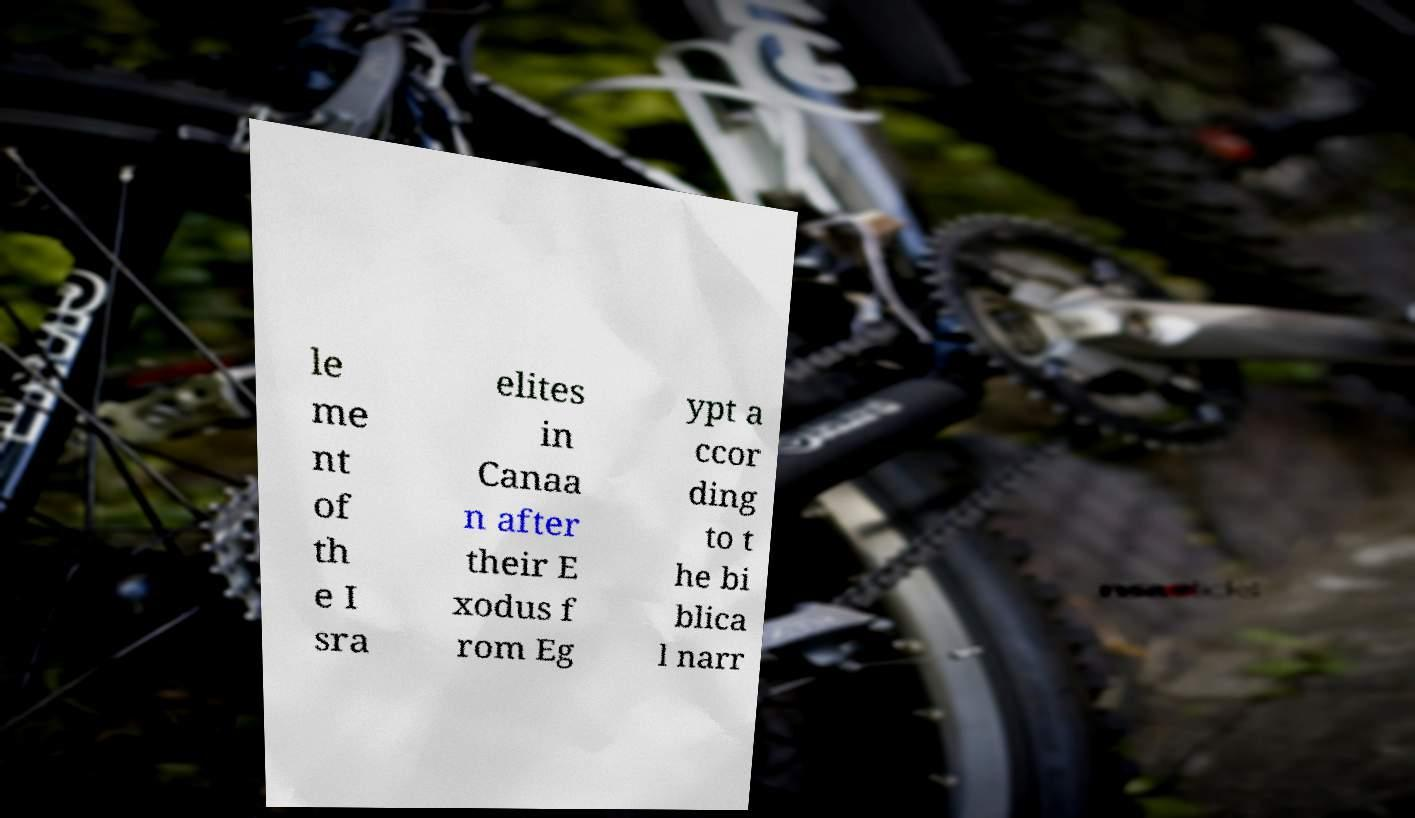There's text embedded in this image that I need extracted. Can you transcribe it verbatim? le me nt of th e I sra elites in Canaa n after their E xodus f rom Eg ypt a ccor ding to t he bi blica l narr 